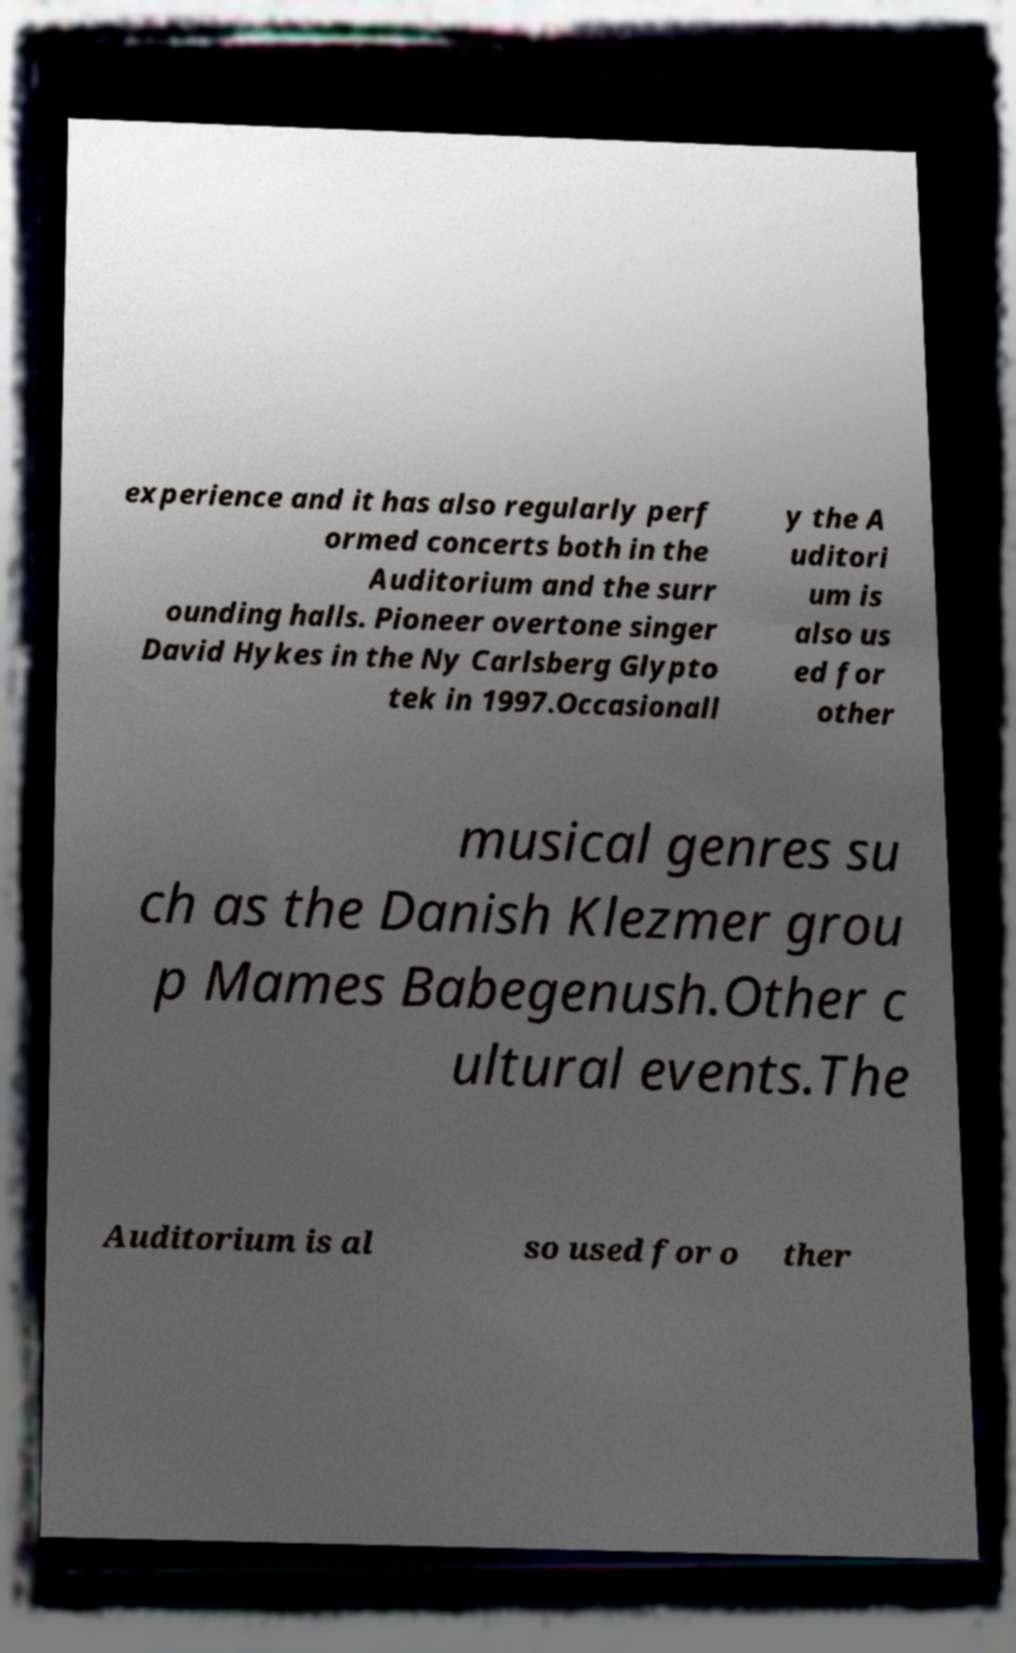Can you read and provide the text displayed in the image?This photo seems to have some interesting text. Can you extract and type it out for me? experience and it has also regularly perf ormed concerts both in the Auditorium and the surr ounding halls. Pioneer overtone singer David Hykes in the Ny Carlsberg Glypto tek in 1997.Occasionall y the A uditori um is also us ed for other musical genres su ch as the Danish Klezmer grou p Mames Babegenush.Other c ultural events.The Auditorium is al so used for o ther 